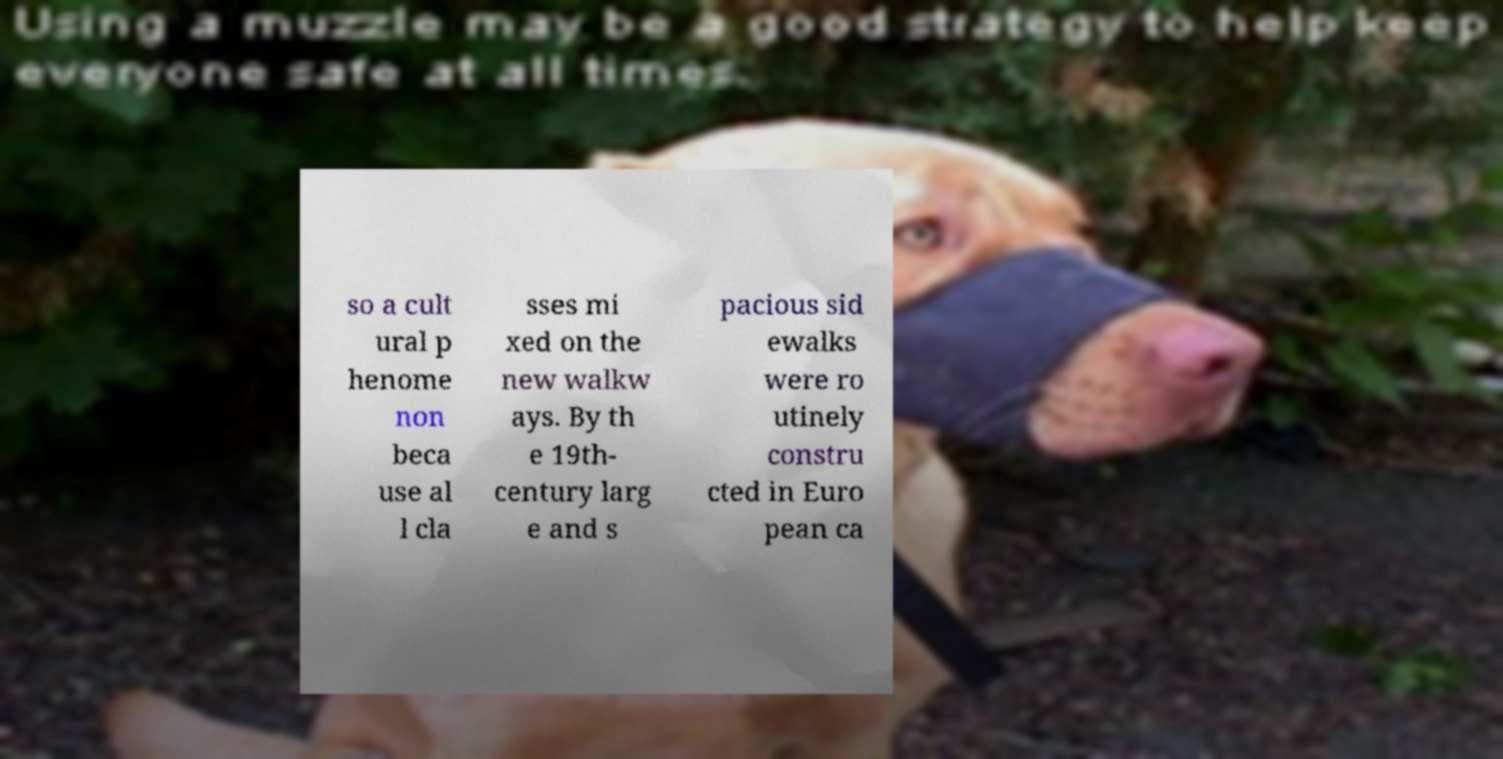I need the written content from this picture converted into text. Can you do that? so a cult ural p henome non beca use al l cla sses mi xed on the new walkw ays. By th e 19th- century larg e and s pacious sid ewalks were ro utinely constru cted in Euro pean ca 